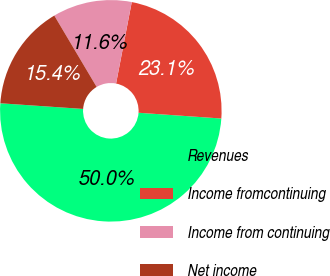Convert chart. <chart><loc_0><loc_0><loc_500><loc_500><pie_chart><fcel>Revenues<fcel>Income fromcontinuing<fcel>Income from continuing<fcel>Net income<nl><fcel>49.98%<fcel>23.08%<fcel>11.55%<fcel>15.39%<nl></chart> 